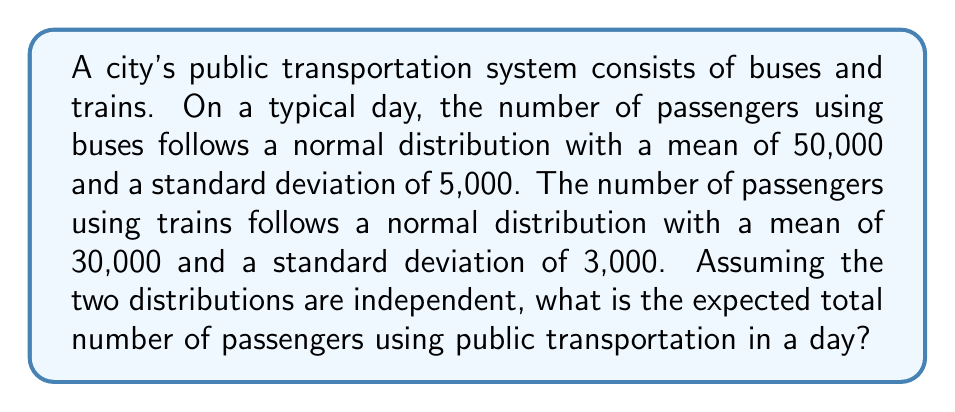Show me your answer to this math problem. To solve this problem, we need to understand the properties of expected values and normal distributions:

1. The expected value of a normal distribution is equal to its mean.
2. For independent random variables, the expected value of their sum is equal to the sum of their individual expected values.

Let's define our random variables:
$X$ = Number of passengers using buses
$Y$ = Number of passengers using trains

We're given:
$X \sim N(50000, 5000^2)$
$Y \sim N(30000, 3000^2)$

The expected value of $X$ is:
$E(X) = 50000$

The expected value of $Y$ is:
$E(Y) = 30000$

Since $X$ and $Y$ are independent, the expected total number of passengers is:

$E(X + Y) = E(X) + E(Y)$

$E(X + Y) = 50000 + 30000 = 80000$

Therefore, the expected total number of passengers using public transportation in a day is 80,000.
Answer: 80,000 passengers 